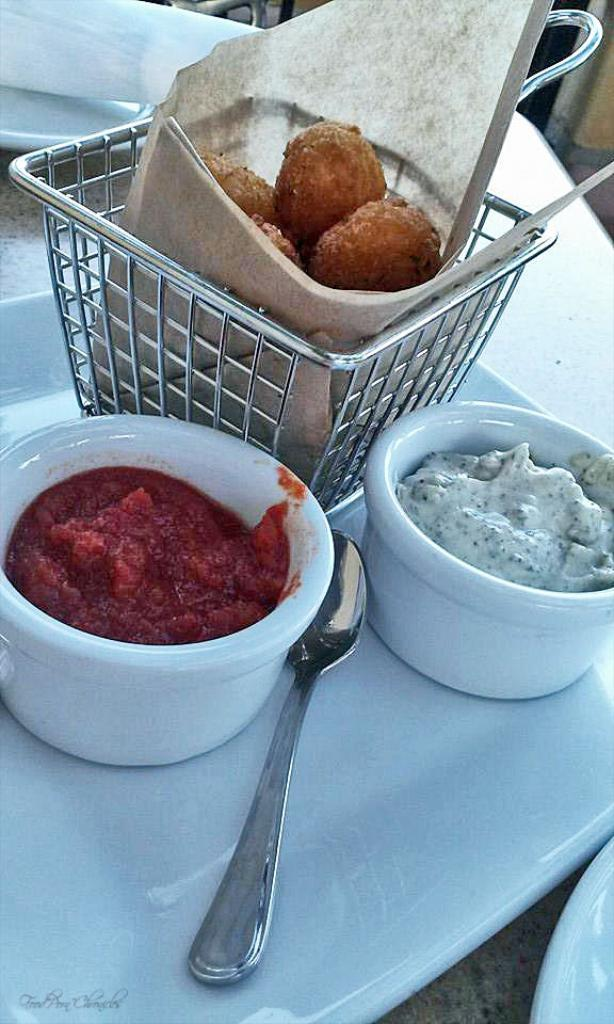What is the main object on the serving plate in the image? The serving plate has nuggets in a bucket. What accompanies the nuggets on the serving plate? There are dips in bowls on the serving plate. What utensil is present on the serving plate? There is a spoon on the serving plate. What type of cactus is present on the serving plate in the image? There is no cactus present on the serving plate in the image. What type of furniture is visible in the image? The provided facts do not mention any furniture in the image. 